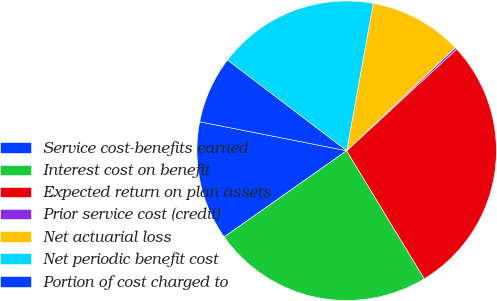Convert chart. <chart><loc_0><loc_0><loc_500><loc_500><pie_chart><fcel>Service cost-benefits earned<fcel>Interest cost on benefit<fcel>Expected return on plan assets<fcel>Prior service cost (credit)<fcel>Net actuarial loss<fcel>Net periodic benefit cost<fcel>Portion of cost charged to<nl><fcel>12.86%<fcel>23.91%<fcel>28.19%<fcel>0.23%<fcel>10.06%<fcel>17.49%<fcel>7.26%<nl></chart> 